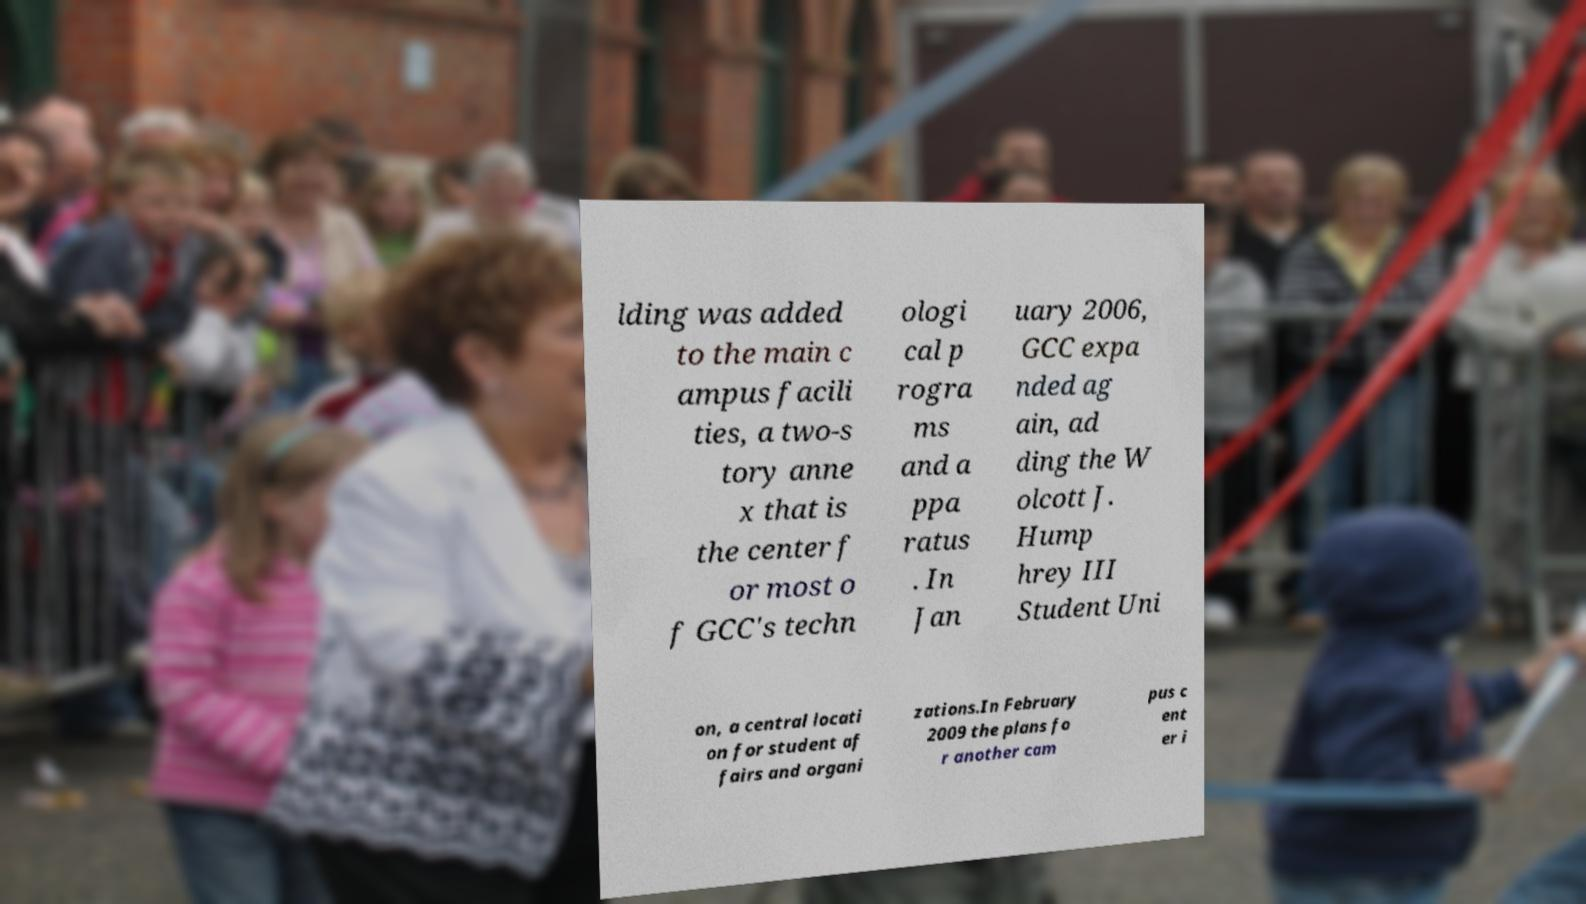Please identify and transcribe the text found in this image. lding was added to the main c ampus facili ties, a two-s tory anne x that is the center f or most o f GCC's techn ologi cal p rogra ms and a ppa ratus . In Jan uary 2006, GCC expa nded ag ain, ad ding the W olcott J. Hump hrey III Student Uni on, a central locati on for student af fairs and organi zations.In February 2009 the plans fo r another cam pus c ent er i 